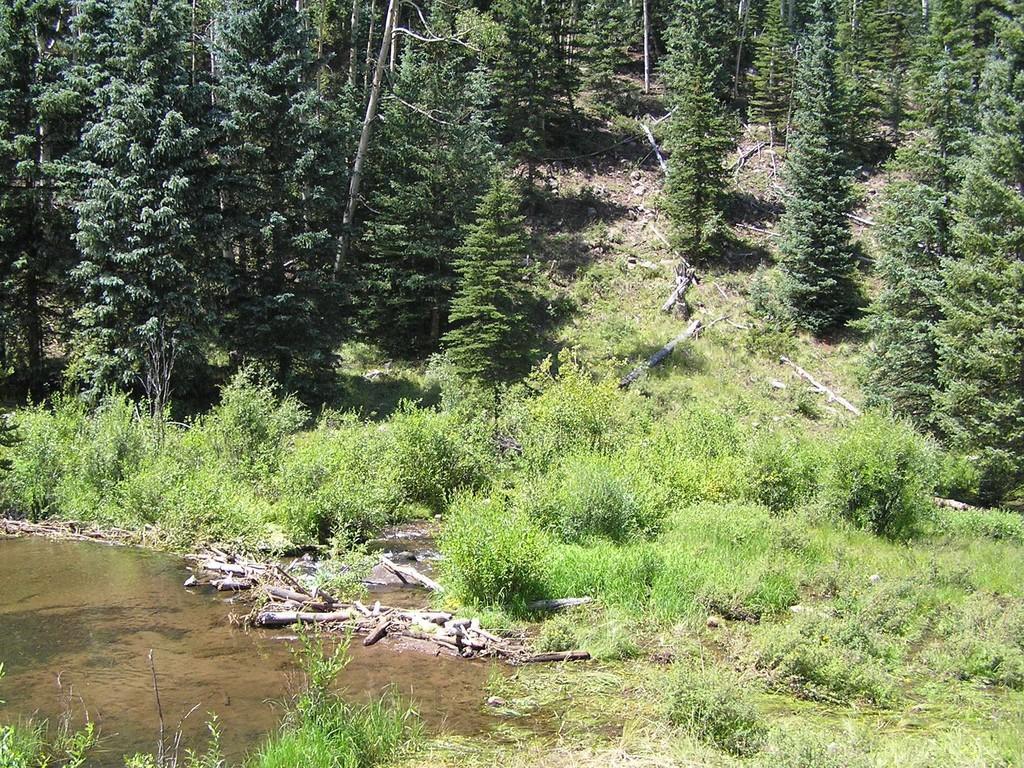In one or two sentences, can you explain what this image depicts? On the left side of the image we can see water, and we can find few plants, wooden barks and trees. 